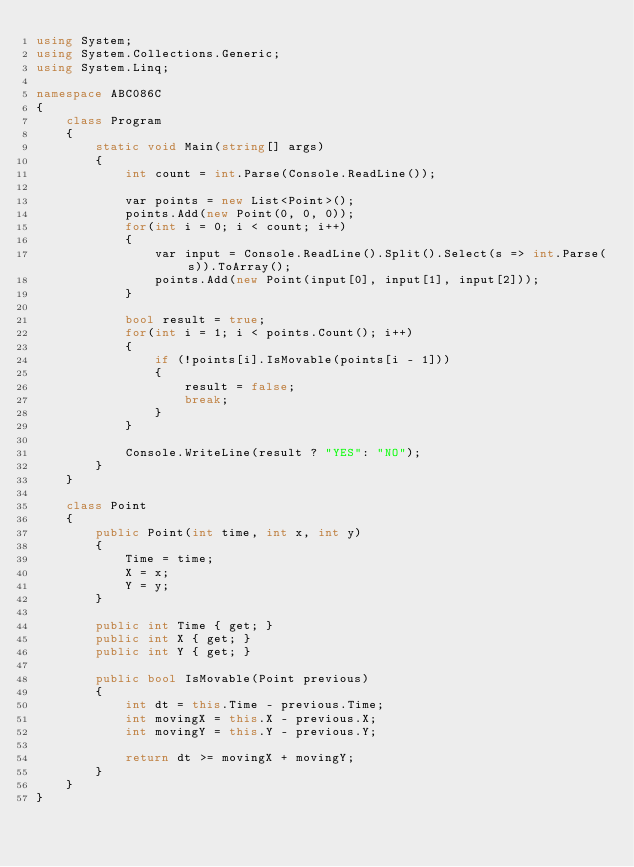<code> <loc_0><loc_0><loc_500><loc_500><_C#_>using System;
using System.Collections.Generic;
using System.Linq;

namespace ABC086C
{
    class Program
    {
        static void Main(string[] args)
        {
            int count = int.Parse(Console.ReadLine());

            var points = new List<Point>();
            points.Add(new Point(0, 0, 0));
            for(int i = 0; i < count; i++)
            {
                var input = Console.ReadLine().Split().Select(s => int.Parse(s)).ToArray();
                points.Add(new Point(input[0], input[1], input[2]));
            }

            bool result = true;
            for(int i = 1; i < points.Count(); i++)
            {
                if (!points[i].IsMovable(points[i - 1]))
                {
                    result = false;
                    break;
                }
            }

            Console.WriteLine(result ? "YES": "NO");
        }
    }

    class Point
    {
        public Point(int time, int x, int y)
        {
            Time = time;
            X = x;
            Y = y;
        }

        public int Time { get; }
        public int X { get; }
        public int Y { get; }

        public bool IsMovable(Point previous)
        {
            int dt = this.Time - previous.Time;
            int movingX = this.X - previous.X;
            int movingY = this.Y - previous.Y;

            return dt >= movingX + movingY;
        }
    }
}
</code> 